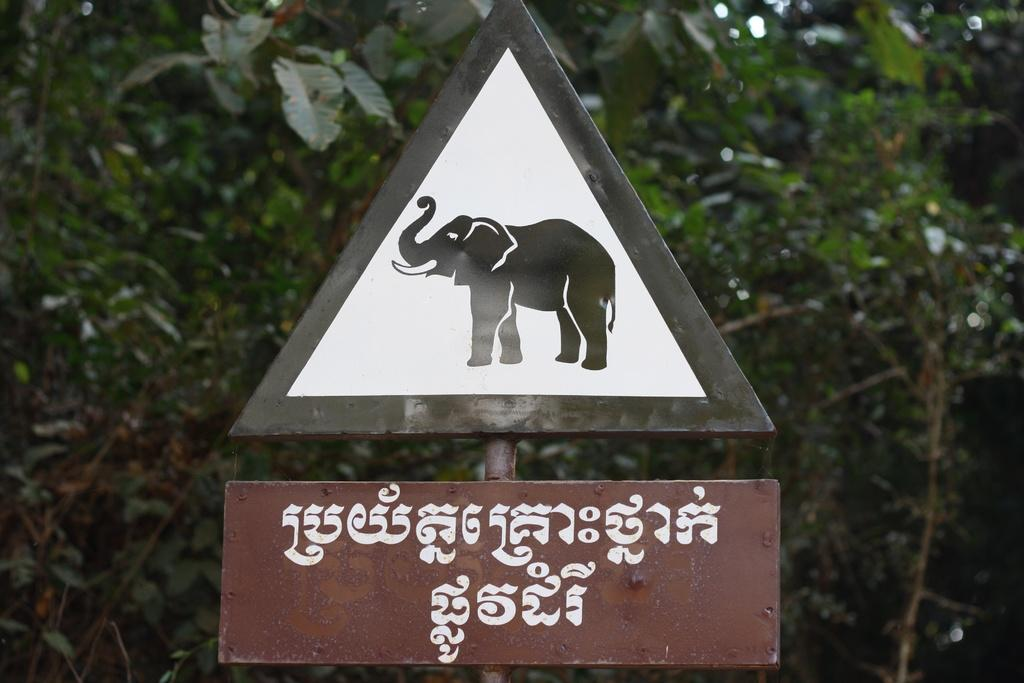What is attached to the pole in the image? There are sign boards on a pole in the image. What type of vegetation can be seen in the image? There are trees visible in the image. What type of linen is being used to dry on the trees in the image? There is no linen visible in the image; only trees and sign boards on a pole are present. How much money can be seen on the trees in the image? There is no money present in the image; only trees and sign boards on a pole are visible. 